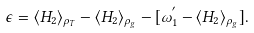<formula> <loc_0><loc_0><loc_500><loc_500>\epsilon = \langle H _ { 2 } \rangle _ { \rho _ { T } } - \langle H _ { 2 } \rangle _ { \rho _ { g } } - [ \omega _ { 1 } ^ { ^ { \prime } } - \langle H _ { 2 } \rangle _ { \rho _ { g } } ] .</formula> 